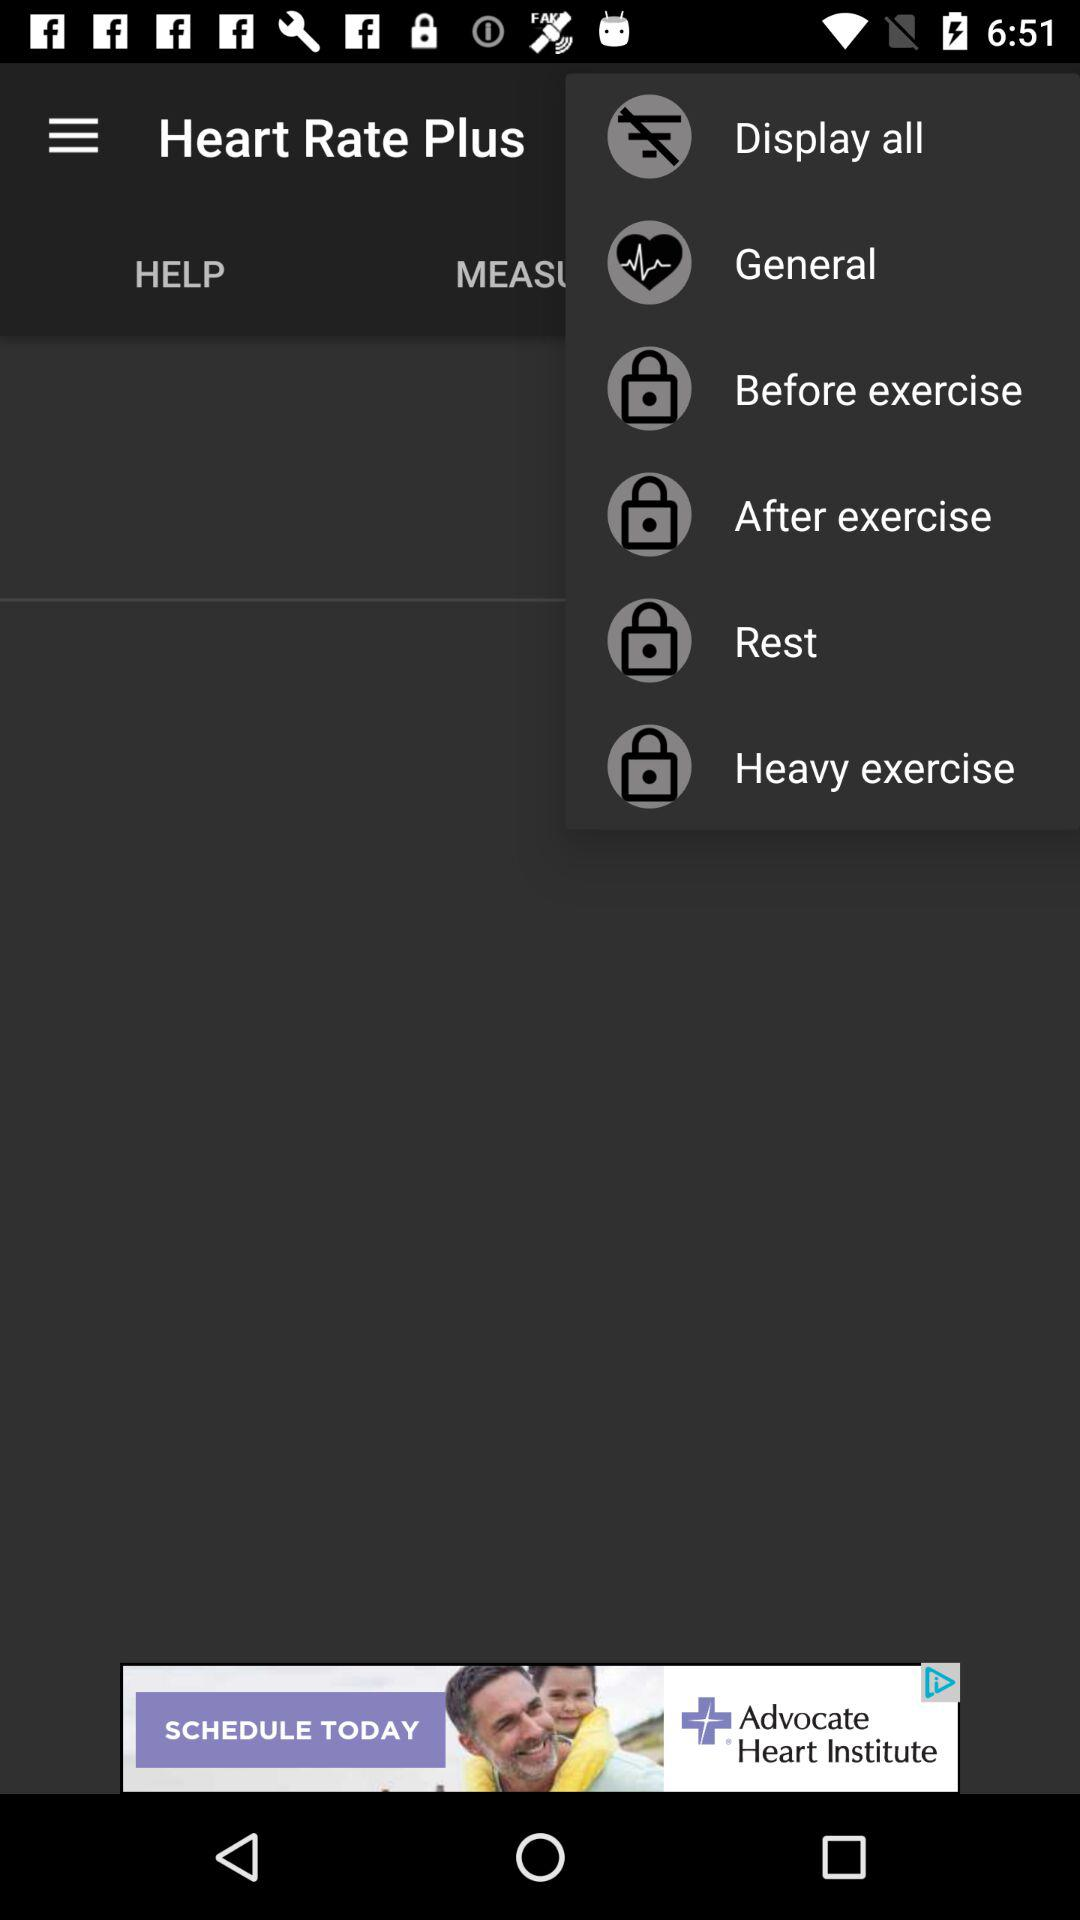How many items are locked?
Answer the question using a single word or phrase. 4 